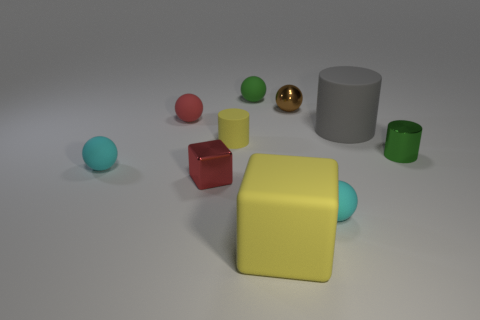There is a cyan object on the left side of the small brown thing to the right of the green object that is left of the gray matte cylinder; what shape is it?
Your answer should be compact. Sphere. Is the number of green metallic things on the left side of the brown object less than the number of large matte cylinders that are in front of the big yellow object?
Offer a very short reply. No. What is the shape of the green object on the left side of the shiny object that is behind the tiny green cylinder?
Give a very brief answer. Sphere. Is there any other thing of the same color as the small shiny cylinder?
Keep it short and to the point. Yes. Is the color of the small cube the same as the rubber block?
Give a very brief answer. No. How many gray things are either small metallic balls or big cylinders?
Offer a terse response. 1. Are there fewer small brown metal balls on the left side of the big cube than cyan metal things?
Your response must be concise. No. There is a cube to the right of the small green matte ball; how many green balls are to the right of it?
Offer a terse response. 0. How many other objects are there of the same size as the metallic cylinder?
Give a very brief answer. 7. How many things are either small green shiny cylinders or cylinders that are on the left side of the yellow matte cube?
Provide a short and direct response. 2. 